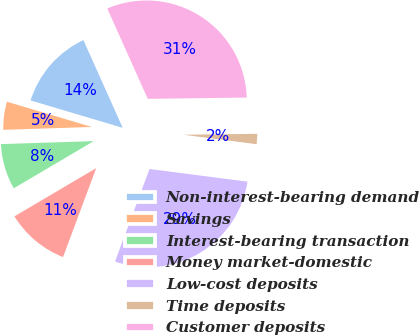Convert chart. <chart><loc_0><loc_0><loc_500><loc_500><pie_chart><fcel>Non-interest-bearing demand<fcel>Savings<fcel>Interest-bearing transaction<fcel>Money market-domestic<fcel>Low-cost deposits<fcel>Time deposits<fcel>Customer deposits<nl><fcel>13.7%<fcel>5.11%<fcel>7.97%<fcel>10.84%<fcel>28.64%<fcel>2.25%<fcel>31.5%<nl></chart> 